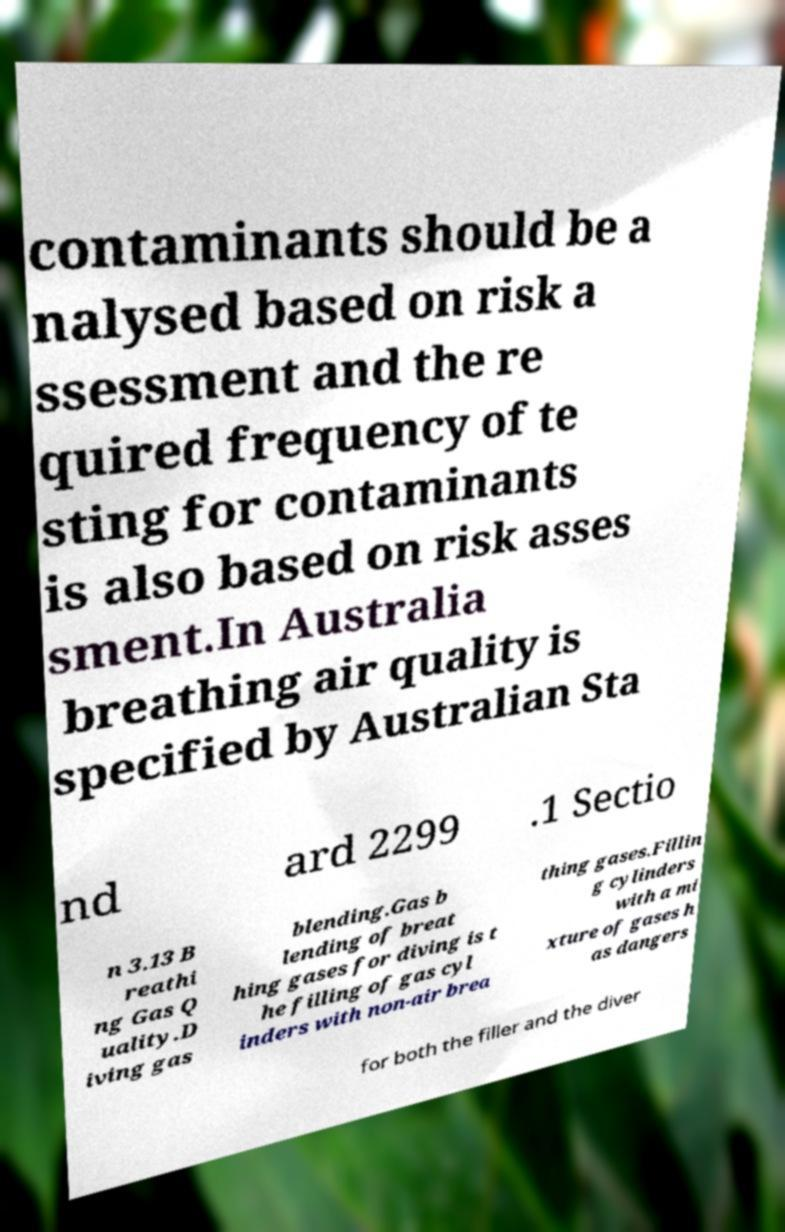For documentation purposes, I need the text within this image transcribed. Could you provide that? contaminants should be a nalysed based on risk a ssessment and the re quired frequency of te sting for contaminants is also based on risk asses sment.In Australia breathing air quality is specified by Australian Sta nd ard 2299 .1 Sectio n 3.13 B reathi ng Gas Q uality.D iving gas blending.Gas b lending of breat hing gases for diving is t he filling of gas cyl inders with non-air brea thing gases.Fillin g cylinders with a mi xture of gases h as dangers for both the filler and the diver 